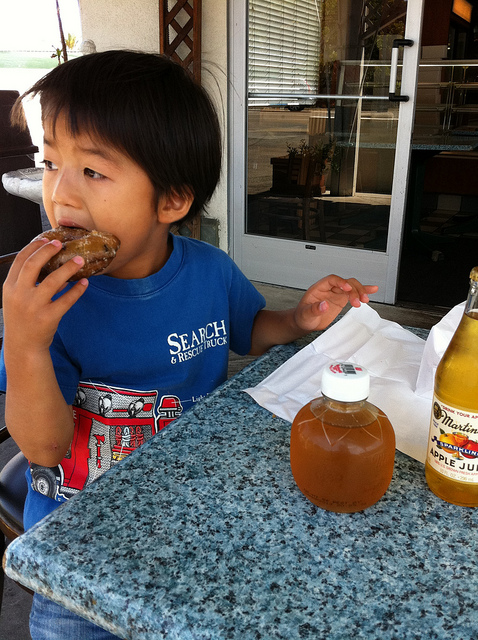Read and extract the text from this image. SEARCH SEARLFI Martin APPLE JU 